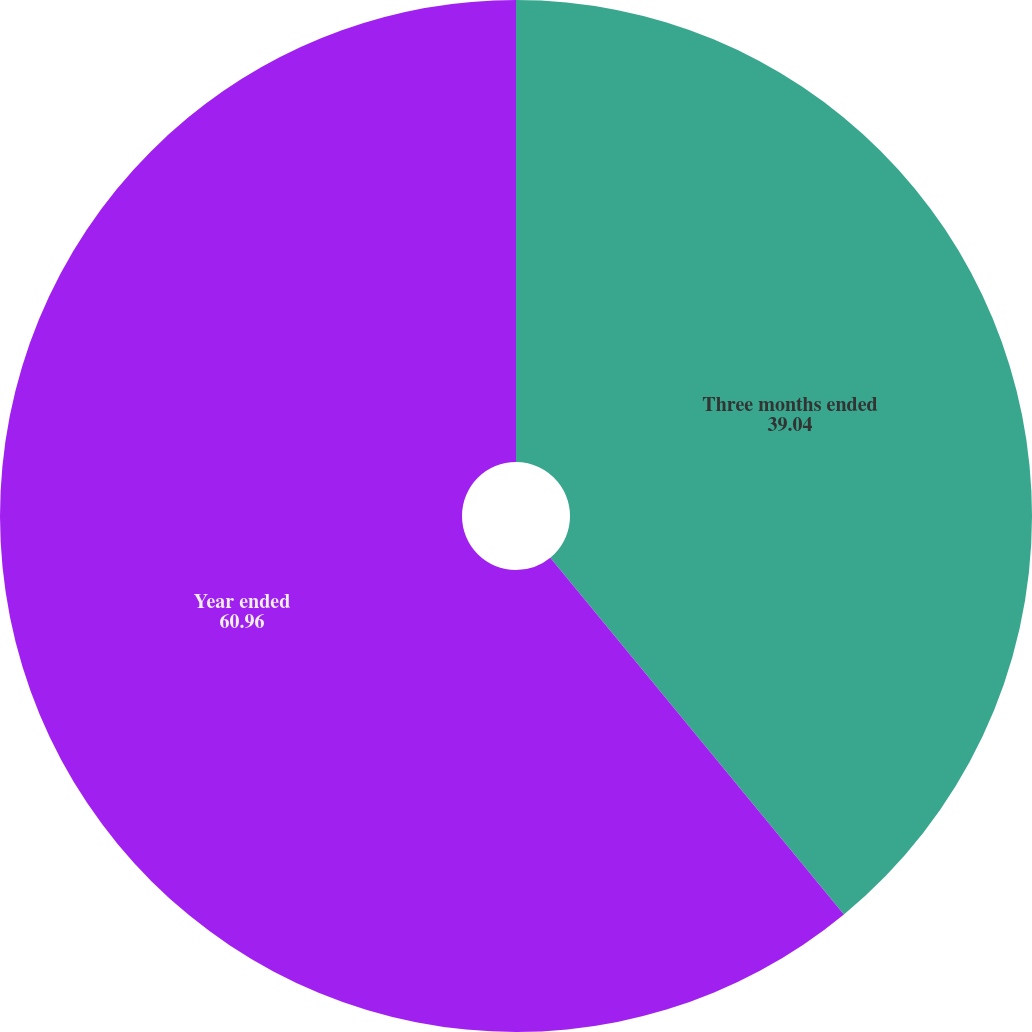Convert chart. <chart><loc_0><loc_0><loc_500><loc_500><pie_chart><fcel>Three months ended<fcel>Year ended<nl><fcel>39.04%<fcel>60.96%<nl></chart> 